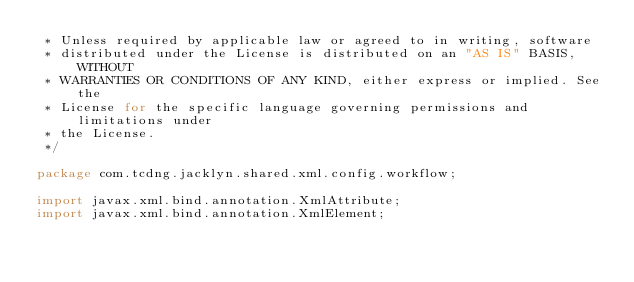Convert code to text. <code><loc_0><loc_0><loc_500><loc_500><_Java_> * Unless required by applicable law or agreed to in writing, software
 * distributed under the License is distributed on an "AS IS" BASIS, WITHOUT
 * WARRANTIES OR CONDITIONS OF ANY KIND, either express or implied. See the
 * License for the specific language governing permissions and limitations under
 * the License.
 */

package com.tcdng.jacklyn.shared.xml.config.workflow;

import javax.xml.bind.annotation.XmlAttribute;
import javax.xml.bind.annotation.XmlElement;</code> 